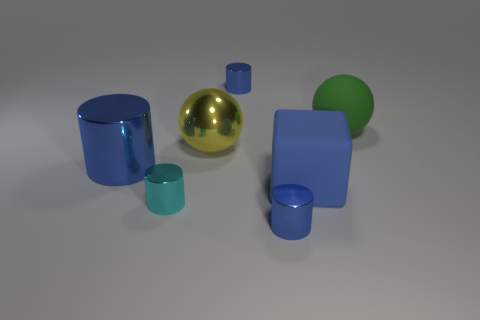The large object that is right of the big yellow shiny ball and behind the cube is made of what material?
Your response must be concise. Rubber. How many big yellow shiny objects have the same shape as the big green matte thing?
Your response must be concise. 1. What number of other objects are the same size as the yellow shiny object?
Ensure brevity in your answer.  3. The small cylinder behind the blue cylinder that is on the left side of the blue shiny cylinder that is behind the green rubber thing is made of what material?
Offer a terse response. Metal. What number of things are either big purple rubber cylinders or blue cylinders?
Your answer should be very brief. 3. The green matte thing is what shape?
Provide a succinct answer. Sphere. The large matte thing that is behind the large blue thing on the left side of the blue cube is what shape?
Offer a terse response. Sphere. Are the blue block that is in front of the large rubber ball and the cyan cylinder made of the same material?
Provide a short and direct response. No. How many yellow objects are either big blocks or big shiny spheres?
Provide a short and direct response. 1. Is there a big metal object of the same color as the cube?
Your answer should be compact. Yes. 